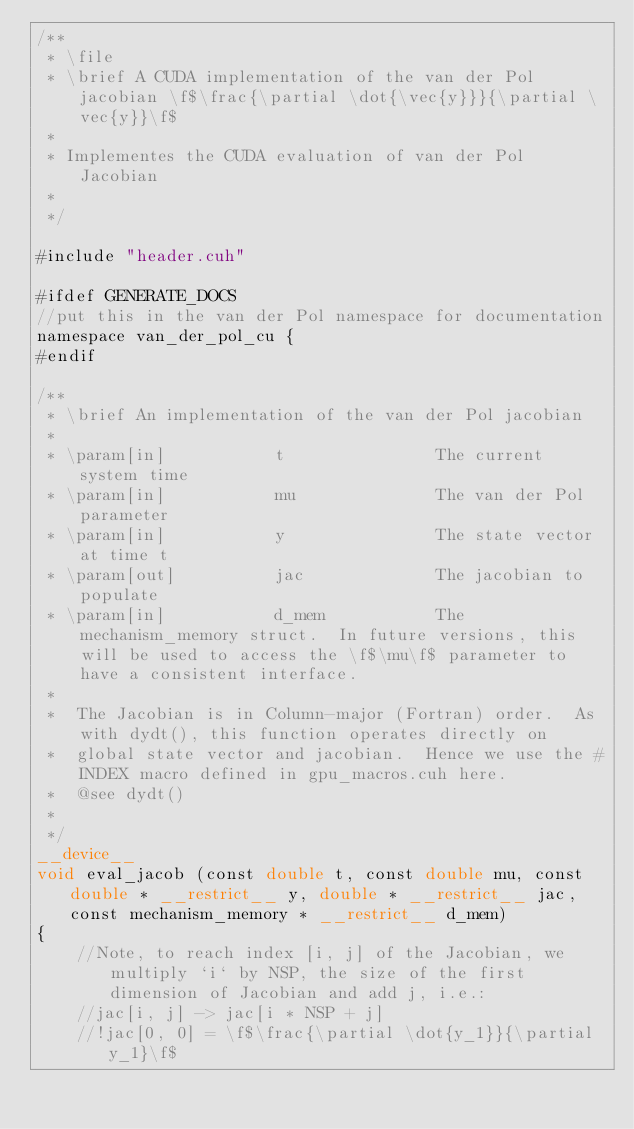<code> <loc_0><loc_0><loc_500><loc_500><_Cuda_>/**
 * \file
 * \brief A CUDA implementation of the van der Pol jacobian \f$\frac{\partial \dot{\vec{y}}}{\partial \vec{y}}\f$
 *
 * Implementes the CUDA evaluation of van der Pol Jacobian
 *
 */

#include "header.cuh"

#ifdef GENERATE_DOCS
//put this in the van der Pol namespace for documentation
namespace van_der_pol_cu {
#endif

/**
 * \brief An implementation of the van der Pol jacobian
 *
 * \param[in]           t               The current system time
 * \param[in]           mu              The van der Pol parameter
 * \param[in]           y               The state vector at time t
 * \param[out]          jac             The jacobian to populate
 * \param[in]           d_mem           The mechanism_memory struct.  In future versions, this will be used to access the \f$\mu\f$ parameter to have a consistent interface.
 *
 *  The Jacobian is in Column-major (Fortran) order.  As with dydt(), this function operates directly on
 *  global state vector and jacobian.  Hence we use the #INDEX macro defined in gpu_macros.cuh here.
 *  @see dydt()
 *
 */
__device__
void eval_jacob (const double t, const double mu, const double * __restrict__ y, double * __restrict__ jac, const mechanism_memory * __restrict__ d_mem)
{
    //Note, to reach index [i, j] of the Jacobian, we multiply `i` by NSP, the size of the first dimension of Jacobian and add j, i.e.:
    //jac[i, j] -> jac[i * NSP + j]
    //!jac[0, 0] = \f$\frac{\partial \dot{y_1}}{\partial y_1}\f$</code> 